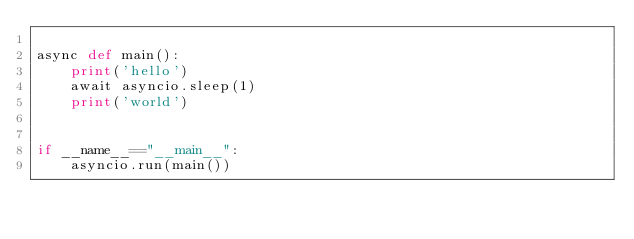<code> <loc_0><loc_0><loc_500><loc_500><_Python_>
async def main():
    print('hello')
    await asyncio.sleep(1)
    print('world')


if __name__=="__main__":
    asyncio.run(main())

</code> 